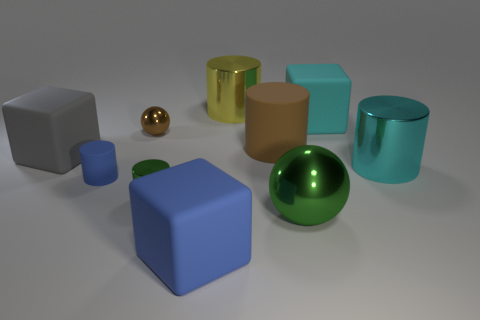Subtract all cyan cylinders. How many cylinders are left? 4 Subtract all big matte cylinders. How many cylinders are left? 4 Subtract 2 cylinders. How many cylinders are left? 3 Subtract all red cylinders. Subtract all purple blocks. How many cylinders are left? 5 Subtract all balls. How many objects are left? 8 Add 5 big metallic objects. How many big metallic objects are left? 8 Add 7 small blue rubber cylinders. How many small blue rubber cylinders exist? 8 Subtract 0 gray cylinders. How many objects are left? 10 Subtract all green metal balls. Subtract all cylinders. How many objects are left? 4 